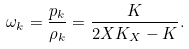<formula> <loc_0><loc_0><loc_500><loc_500>\omega _ { k } = \frac { p _ { k } } { \rho _ { k } } = \frac { K } { 2 X K _ { X } - K } .</formula> 